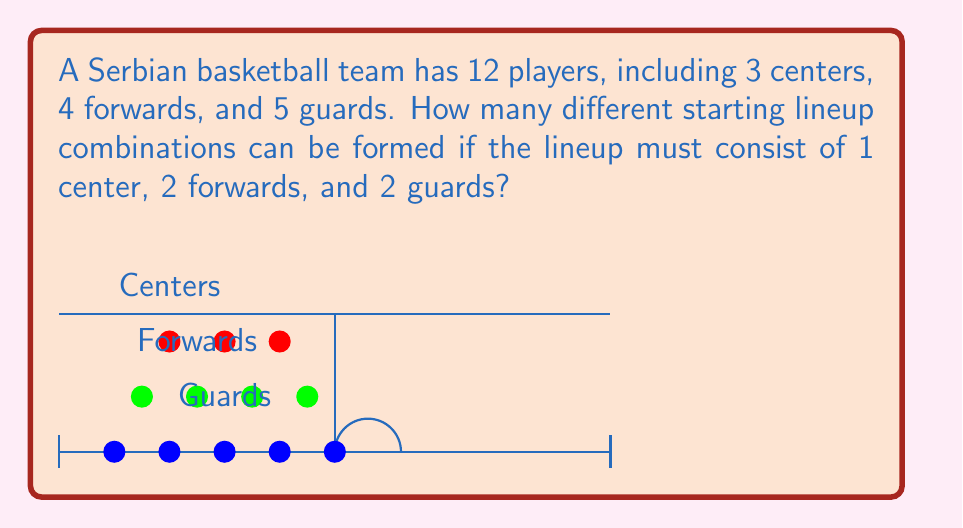Teach me how to tackle this problem. Let's approach this step-by-step using the multiplication principle from combinatorics:

1) First, we need to choose 1 center from 3 available centers:
   $$\binom{3}{1} = 3$$

2) Next, we need to choose 2 forwards from 4 available forwards:
   $$\binom{4}{2} = \frac{4!}{2!(4-2)!} = \frac{4 \cdot 3}{2 \cdot 1} = 6$$

3) Finally, we need to choose 2 guards from 5 available guards:
   $$\binom{5}{2} = \frac{5!}{2!(5-2)!} = \frac{5 \cdot 4}{2 \cdot 1} = 10$$

4) By the multiplication principle, the total number of possible combinations is:
   $$3 \cdot 6 \cdot 10 = 180$$

This calculation represents all possible ways to select 1 from 3, 2 from 4, and 2 from 5, which corresponds to our lineup requirements.
Answer: 180 